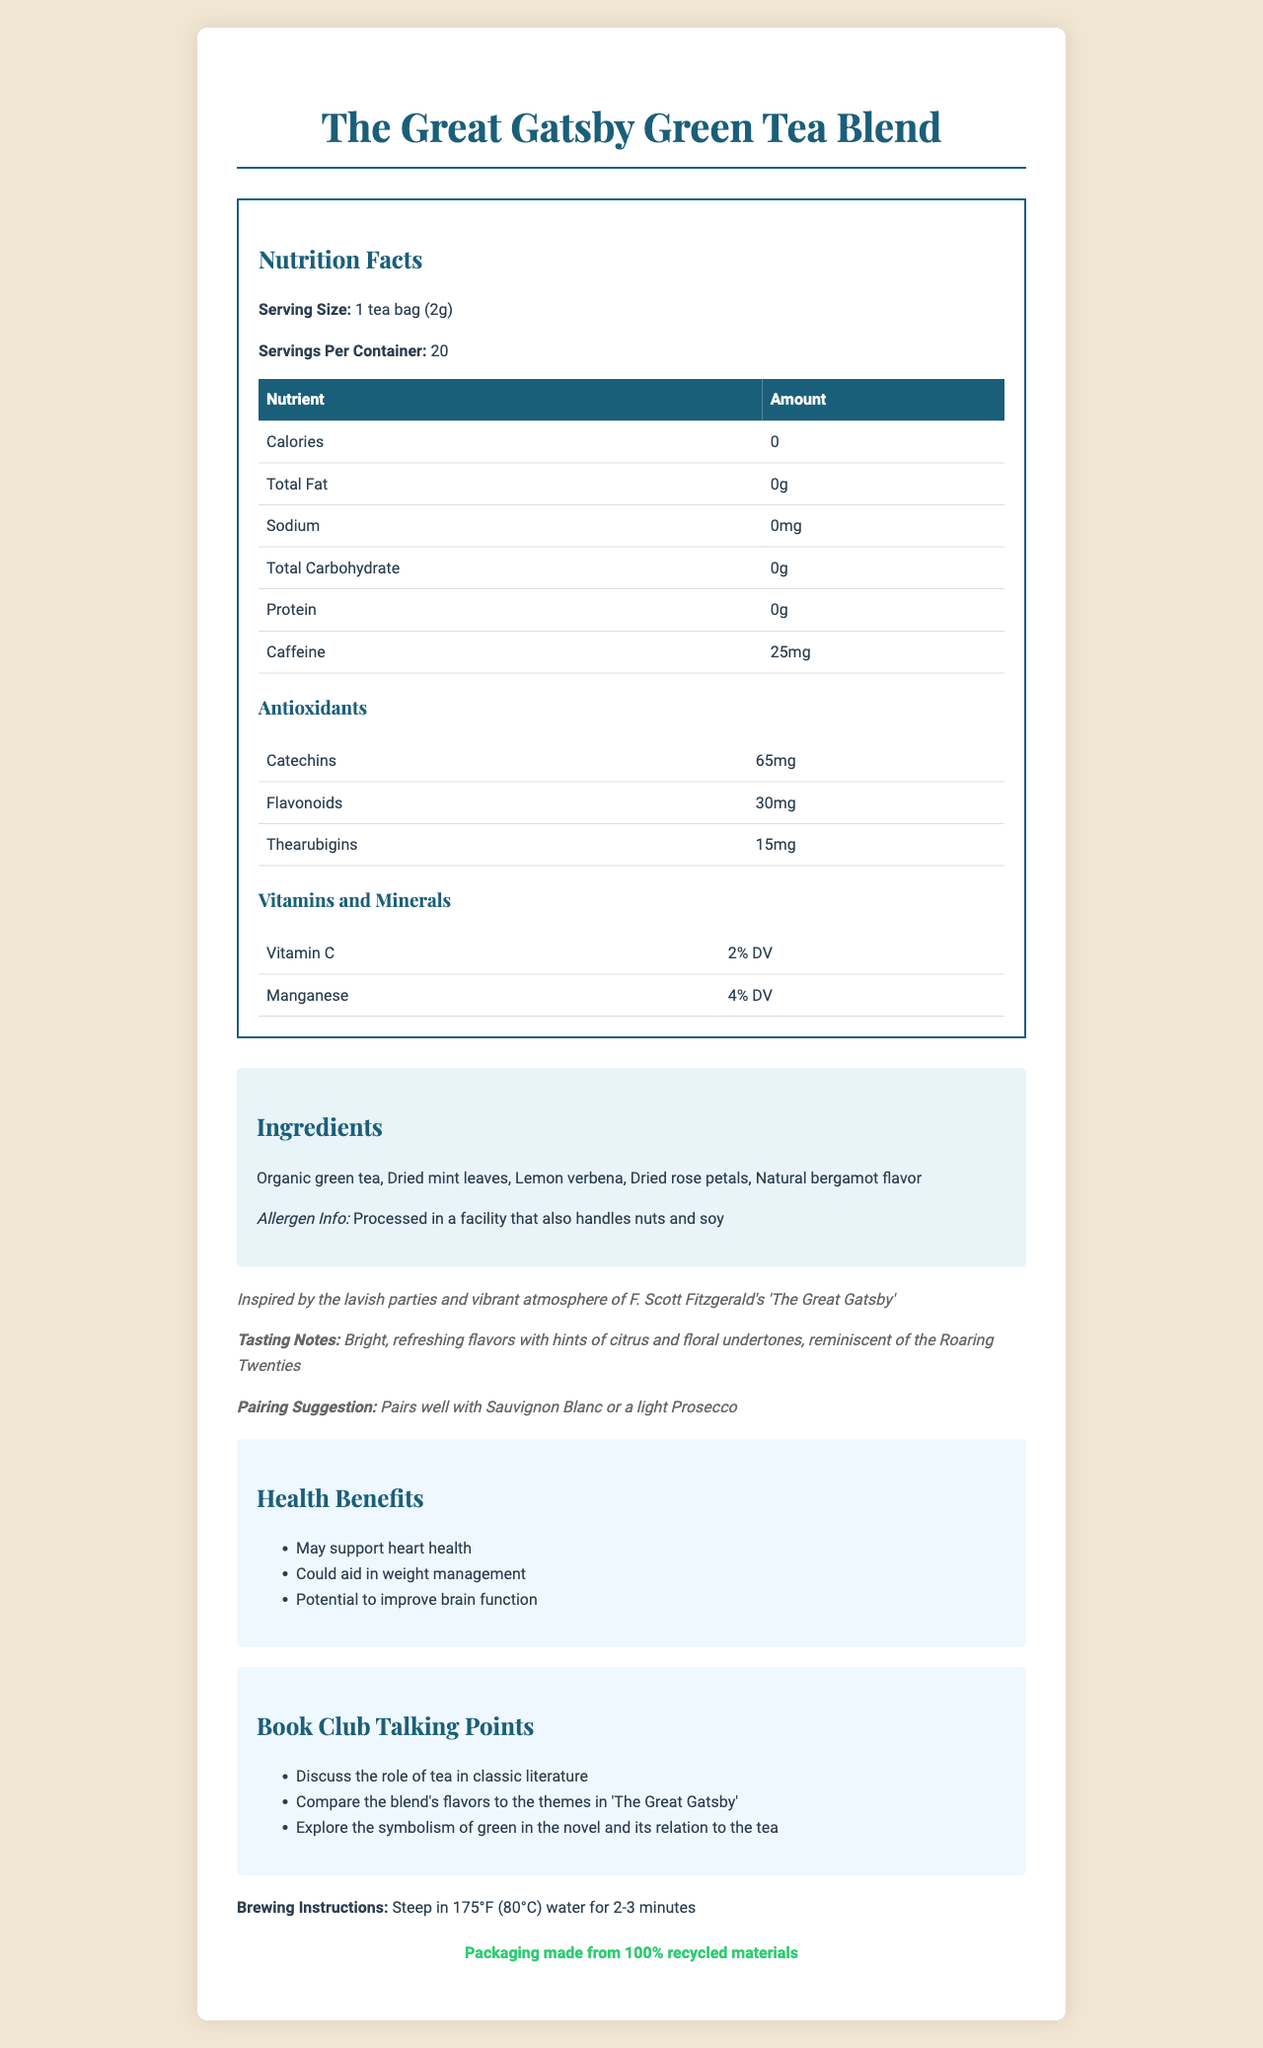what is the serving size? The serving size is stated directly in the "Nutrition Facts" section under "Serving Size."
Answer: 1 tea bag (2g) how many servings are in the container? The document indicates "Servings Per Container: 20" in the "Nutrition Facts" section.
Answer: 20 how much caffeine is in one serving? The "Nutrition Facts" section lists the amount of caffeine per serving as "25mg."
Answer: 25mg what are the antioxidants listed and their amounts? The amounts of antioxidants are detailed in the "Antioxidants" subsection within the "Nutrition Facts" section.
Answer: Catechins: 65mg, Flavonoids: 30mg, Thearubigins: 15mg what flavors can be identified in the tea blend? The "Tasting Notes" subsection under the "literary-note" section describes the flavors.
Answer: Bright, refreshing flavors with hints of citrus and floral undertones what is the per daily value percentage of vitamin C in one serving of the tea? The "Nutrition Facts" section, specifically under the "Vitamins and Minerals" subsection, lists vitamin C as "2% DV."
Answer: 2% DV which mineral in the tea contributes 4% DV? A. Vitamin C B. Manganese C. Iron D. Calcium The "Nutrition Facts" section under "Vitamins and Minerals" lists manganese as contributing "4% DV."
Answer: B what should you pair this tea with according to the document? A. Cabernet Sauvignon B. Chardonnay C. Sauvignon Blanc D. Merlot The "Pairing Suggestion" section suggests pairing the tea with "Sauvignon Blanc or a light Prosecco."
Answer: C is this product suitable for individuals with nut allergies? The document specifies "Processed in a facility that also handles nuts and soy" in the allergen info section.
Answer: No can you find any mention of iron content in this tea? The document does not list iron content under "Vitamins and Minerals."
Answer: No information available summarize the main idea of the document. The document is a detailed overview of the "The Great Gatsby Green Tea Blend," covering its nutritional content, ingredients, taste, pairings, health benefits, and additional features that connect it to literary themes.
Answer: This document presents the "The Great Gatsby Green Tea Blend," an artisanal tea inspired by "The Great Gatsby." It provides details on nutrition facts, including the amount of caffeine and antioxidants. The ingredients are listed, along with allergen information. The tea is noted for its bright, refreshing flavors and is suggested to pair with Sauvignon Blanc or Prosecco. It also mentions possible health benefits, sustainability efforts, and includes book club talking points. 